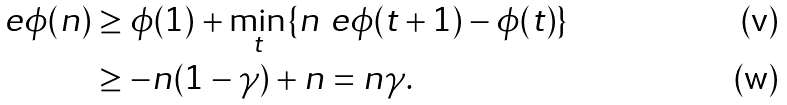Convert formula to latex. <formula><loc_0><loc_0><loc_500><loc_500>\ e { \phi ( n ) } & \geq \phi ( 1 ) + \min _ { t } \{ n \ e { \phi ( t + 1 ) - \phi ( t ) } \} \\ & \geq - n ( 1 - \gamma ) + n = n \gamma .</formula> 